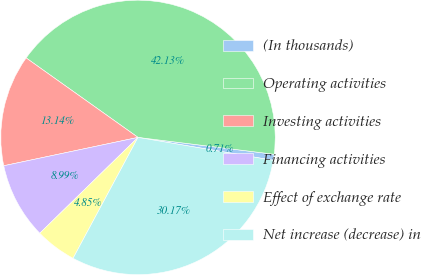Convert chart to OTSL. <chart><loc_0><loc_0><loc_500><loc_500><pie_chart><fcel>(In thousands)<fcel>Operating activities<fcel>Investing activities<fcel>Financing activities<fcel>Effect of exchange rate<fcel>Net increase (decrease) in<nl><fcel>0.71%<fcel>42.13%<fcel>13.14%<fcel>8.99%<fcel>4.85%<fcel>30.17%<nl></chart> 